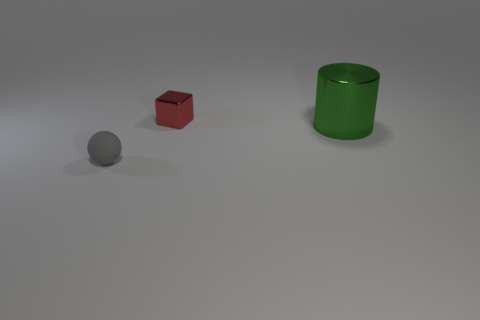Add 3 large green blocks. How many objects exist? 6 Subtract 0 green balls. How many objects are left? 3 Subtract all spheres. How many objects are left? 2 Subtract all blue spheres. Subtract all blue cylinders. How many spheres are left? 1 Subtract all big green cylinders. Subtract all large yellow blocks. How many objects are left? 2 Add 2 large metallic cylinders. How many large metallic cylinders are left? 3 Add 2 big yellow metal balls. How many big yellow metal balls exist? 2 